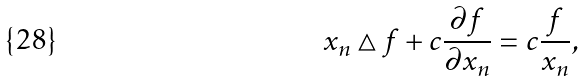Convert formula to latex. <formula><loc_0><loc_0><loc_500><loc_500>x _ { n } \bigtriangleup f + c \frac { \partial f } { \partial x _ { n } } = c \frac { f } { x _ { n } } ,</formula> 